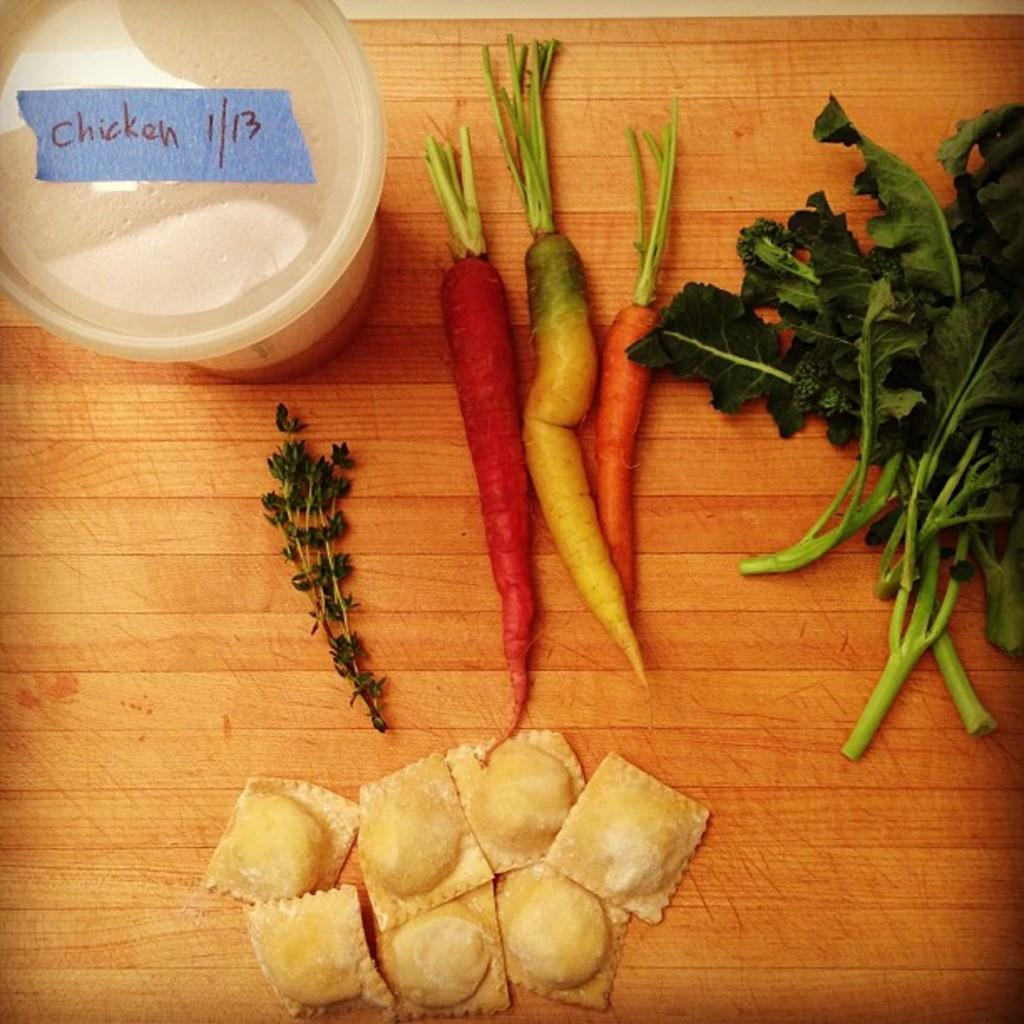What type of vegetables can be seen in the image? There are carrots and leafy vegetables in the image. What is the primary subject of the image? Food is visible in the image. What object can be seen in the image that is not food? There is a box in the image. What is the color of the table in the image? The table in the image is brown in color. What type of thread is being used to create the attraction in the image? There is no attraction or thread present in the image; it features vegetables, food, a box, and a brown table. 